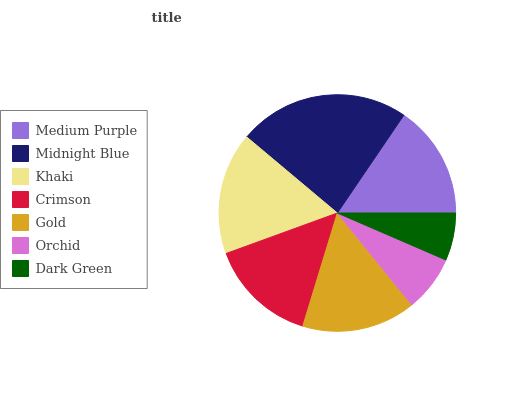Is Dark Green the minimum?
Answer yes or no. Yes. Is Midnight Blue the maximum?
Answer yes or no. Yes. Is Khaki the minimum?
Answer yes or no. No. Is Khaki the maximum?
Answer yes or no. No. Is Midnight Blue greater than Khaki?
Answer yes or no. Yes. Is Khaki less than Midnight Blue?
Answer yes or no. Yes. Is Khaki greater than Midnight Blue?
Answer yes or no. No. Is Midnight Blue less than Khaki?
Answer yes or no. No. Is Medium Purple the high median?
Answer yes or no. Yes. Is Medium Purple the low median?
Answer yes or no. Yes. Is Orchid the high median?
Answer yes or no. No. Is Dark Green the low median?
Answer yes or no. No. 